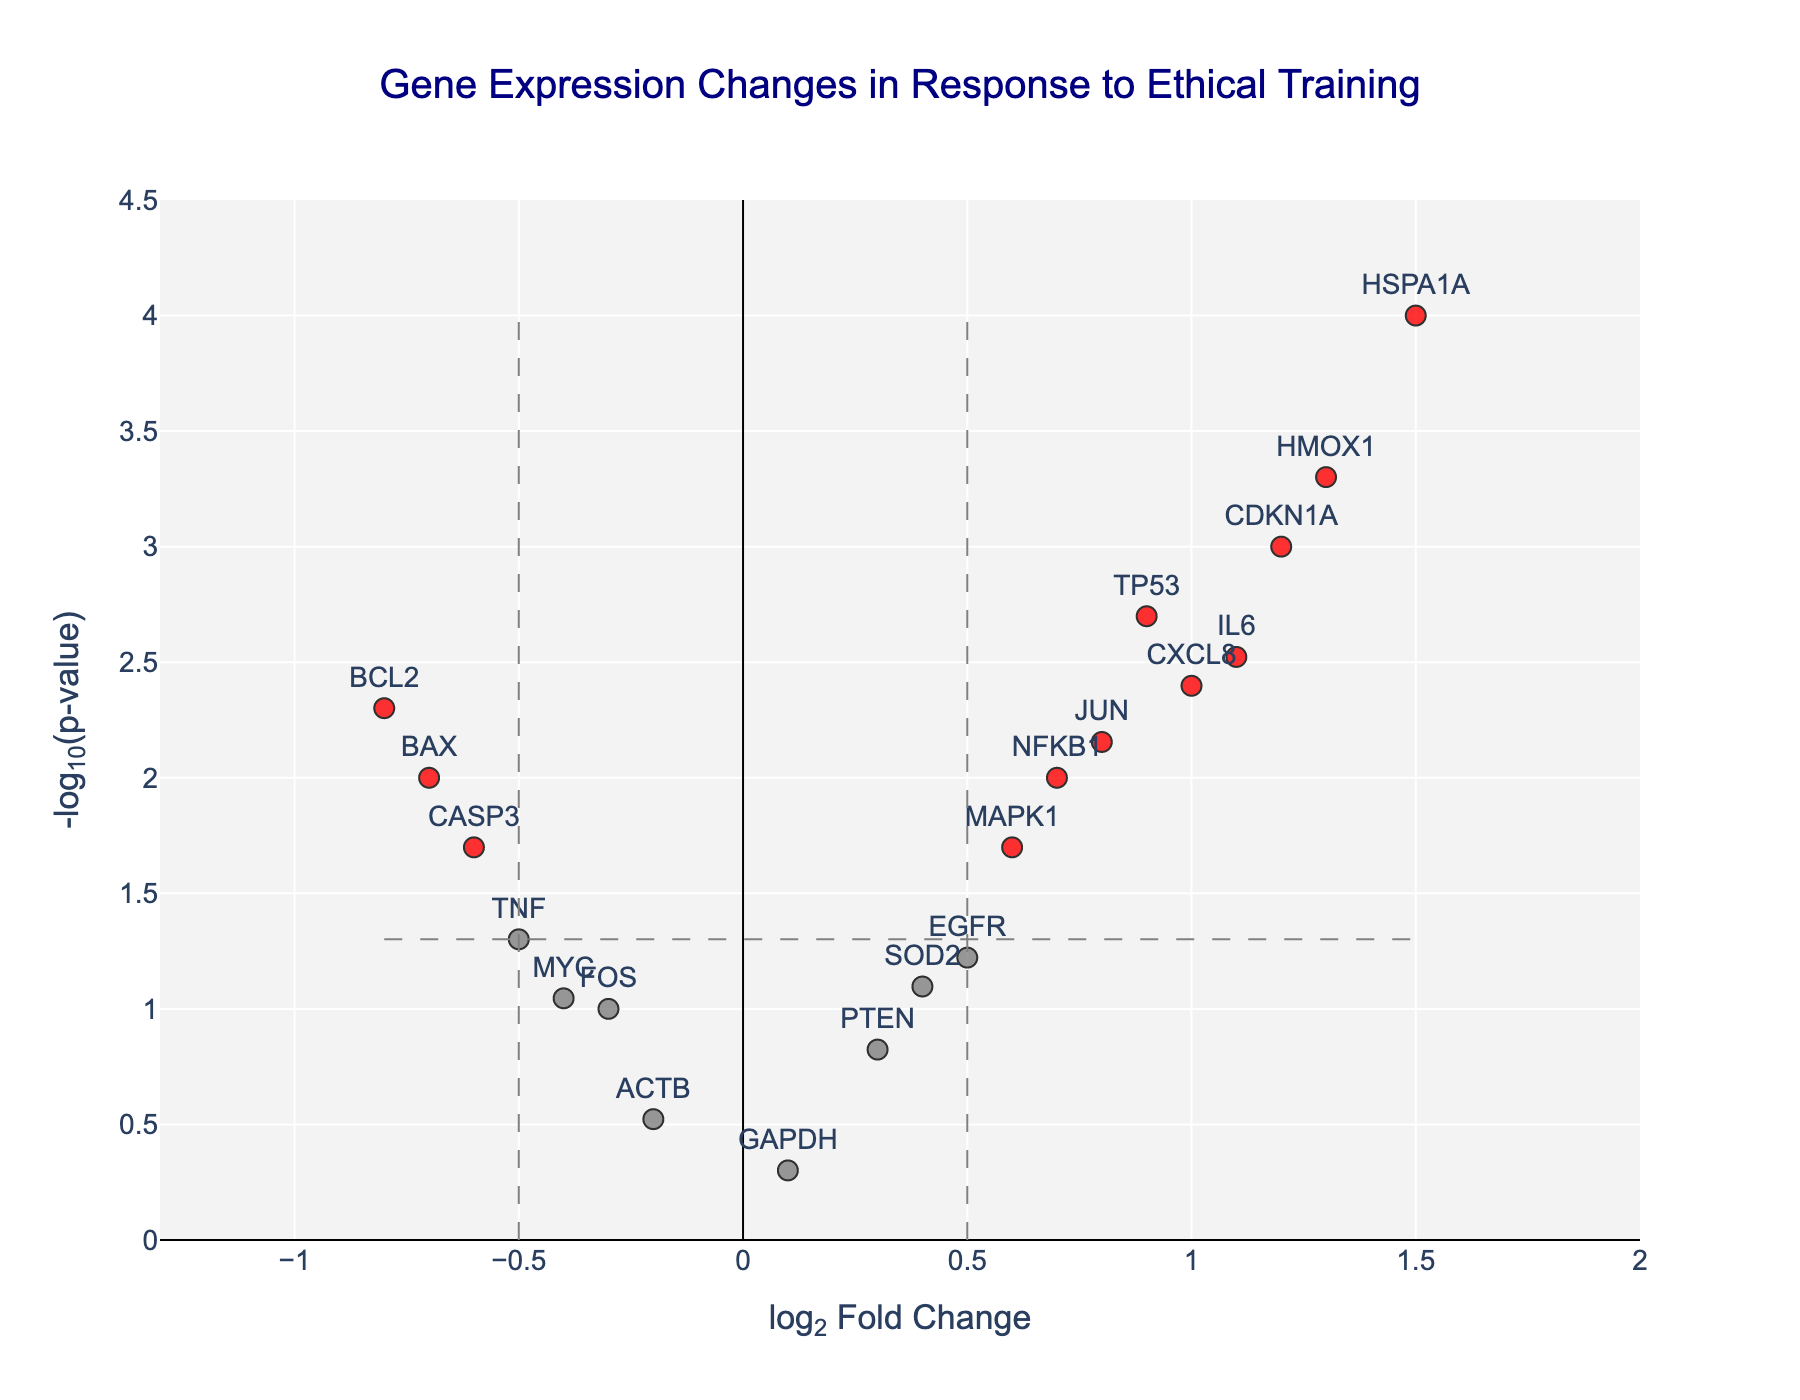What is the title of the figure? The title of the figure is usually displayed at the top.
Answer: Gene Expression Changes in Response to Ethical Training How many genes in total are shown on the plot? Count the number of unique gene labels in the plot.
Answer: 20 Which gene has the highest log2 Fold Change (log2FC) value? Identify the point on the x-axis with the highest log2FC value and note the gene label.
Answer: HSPA1A Which gene has the lowest p-value? Identify the point on the y-axis with the highest -log10(p-value) value and note the gene label.
Answer: HSPA1A How many genes are significantly upregulated? Count the number of red points (significant) with a positive log2FC.
Answer: 6 Which gene(s) show log2 Fold Change approximately equal to 1.2 with a p-value less than 0.01? Look for points with x-values around 1.2 and y-values corresponding to -log10(p < 0.01), and note the gene labels.
Answer: CDKN1A Which genes have non-significant changes in expression? Identify the gray and green points on the plot and note the gene labels.
Answer: TNF, SOD2, FOS, GAPDH, ACTB, EGFR, MYC, PTEN Is the gene NFKB1 significantly differentially expressed? Check if the gene NFKB1 falls in the red or blue category based on its color.
Answer: Yes, it is blue indicating a significant change Which genes have a negative log2 Fold Change less than -0.5 and are also significant? Identify red points on the left side of the plot (log2FC < -0.5) and note the gene labels.
Answer: BCL2, CASP3, BAX What thresholds are used to determine significance in this plot? Identify the dashed lines on the plot indicating thresholds for log2FC and -log10(p-value).
Answer: log2FC of ±0.5 and p-value of 0.05 